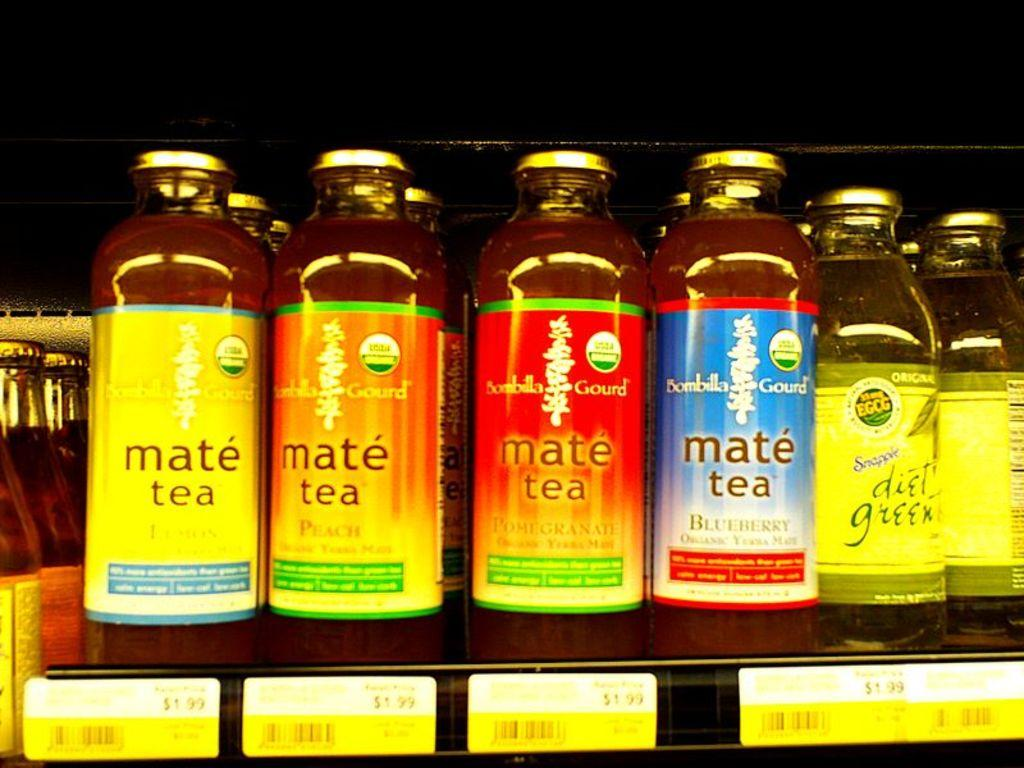<image>
Provide a brief description of the given image. A variety of bottlles of Bombilla Gourd mate tea on a shelf. 